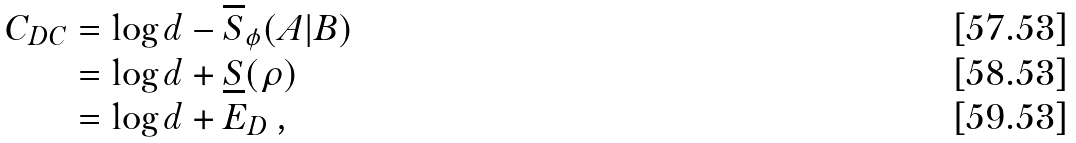Convert formula to latex. <formula><loc_0><loc_0><loc_500><loc_500>C _ { D C } & = \log d - \overline { S } _ { \phi } ( A | B ) \\ & = \log d + \underline { S } ( \rho ) \\ & = \log d + E _ { D } \, ,</formula> 